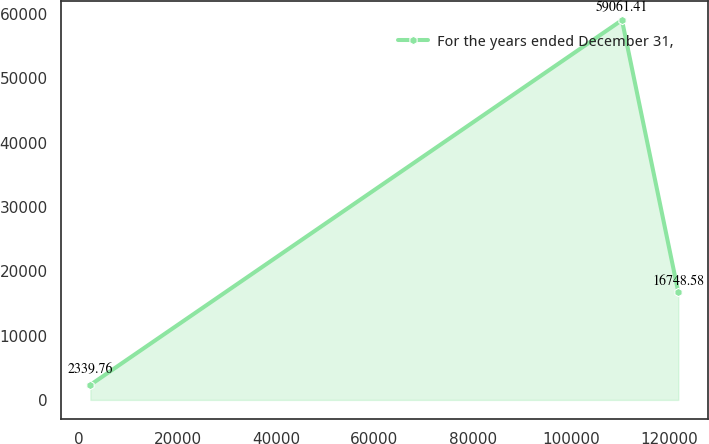<chart> <loc_0><loc_0><loc_500><loc_500><line_chart><ecel><fcel>For the years ended December 31,<nl><fcel>2284.81<fcel>2339.76<nl><fcel>110304<fcel>59061.4<nl><fcel>121755<fcel>16748.6<nl></chart> 